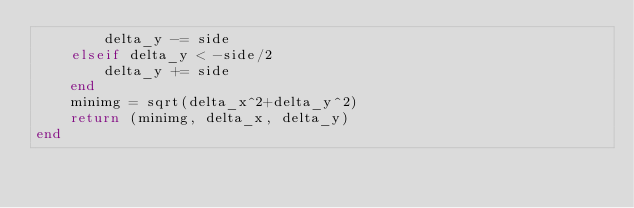<code> <loc_0><loc_0><loc_500><loc_500><_Julia_>        delta_y -= side
    elseif delta_y < -side/2
        delta_y += side 
    end
    minimg = sqrt(delta_x^2+delta_y^2)
    return (minimg, delta_x, delta_y)
end
</code> 